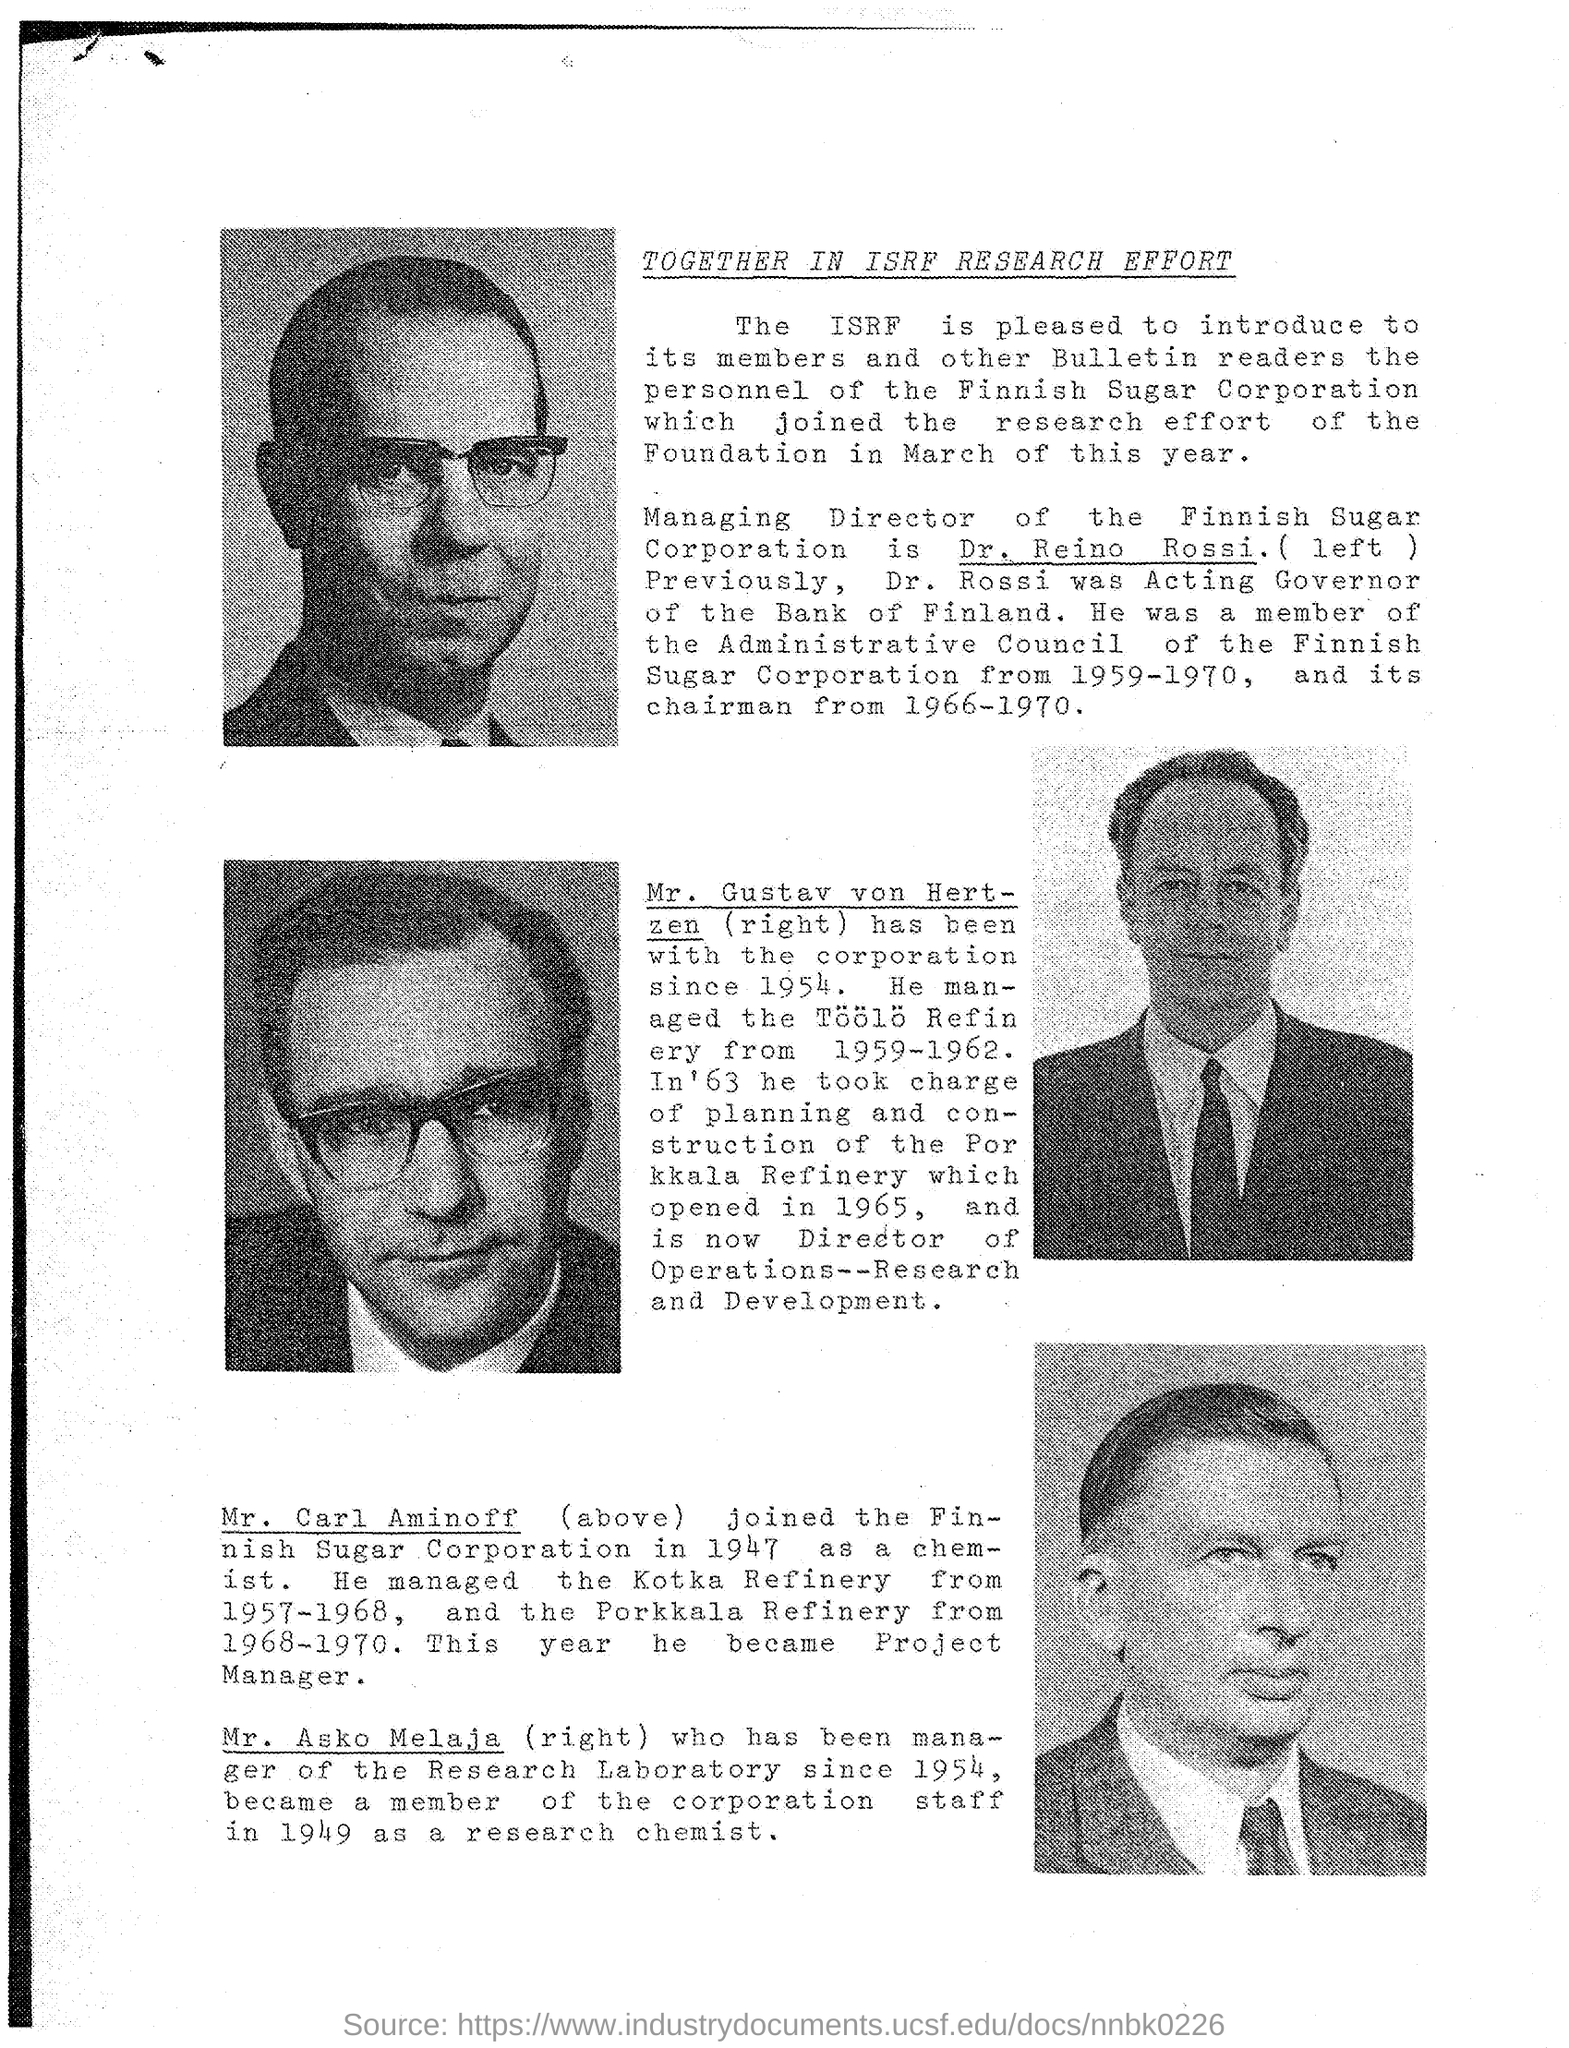Point out several critical features in this image. Mr. Gustav von Hertzen has been with the corporation since 1954. The title of the document is 'Together in ISRF Research Effort.' The Managing Director of Finnish Sugar Corporation is Dr. Reino Rossi. 